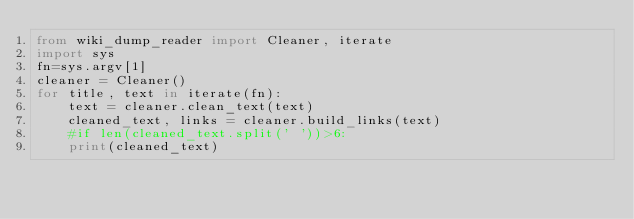Convert code to text. <code><loc_0><loc_0><loc_500><loc_500><_Python_>from wiki_dump_reader import Cleaner, iterate
import sys
fn=sys.argv[1]
cleaner = Cleaner()
for title, text in iterate(fn):
    text = cleaner.clean_text(text)
    cleaned_text, links = cleaner.build_links(text)
    #if len(cleaned_text.split(' '))>6:
    print(cleaned_text)
</code> 